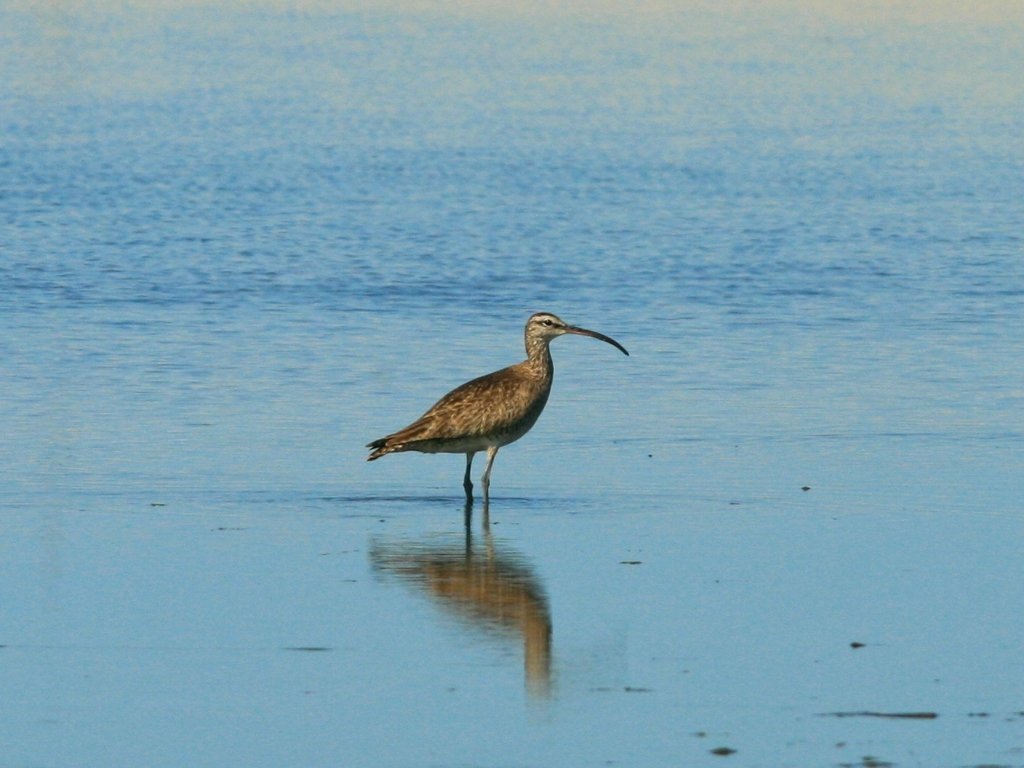How does this image reflect the bird's behavior? The image shows the bird standing alone in a shallow body of water, which is typical foraging behavior for shorebirds like the whimbrel. The stance indicates it is cautiously looking for food, while its isolation from any flock suggests it might be territorial. 